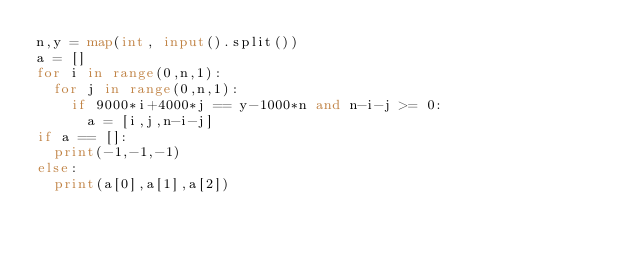<code> <loc_0><loc_0><loc_500><loc_500><_Python_>n,y = map(int, input().split())
a = []
for i in range(0,n,1):
  for j in range(0,n,1):
    if 9000*i+4000*j == y-1000*n and n-i-j >= 0:
      a = [i,j,n-i-j]
if a == []:
  print(-1,-1,-1)
else:
  print(a[0],a[1],a[2])
      </code> 